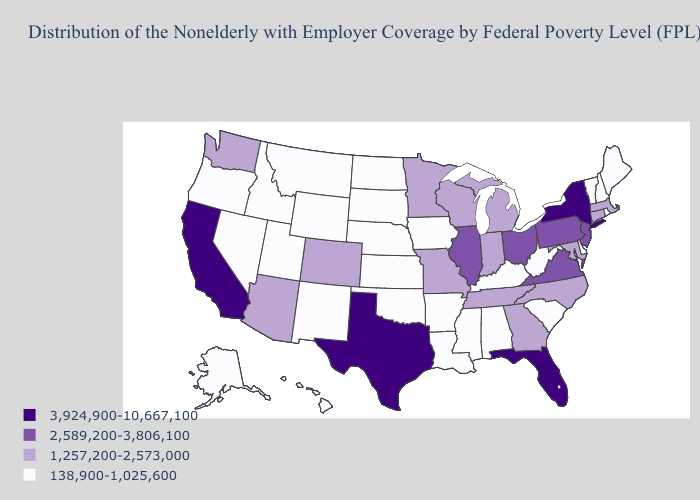What is the value of Indiana?
Give a very brief answer. 1,257,200-2,573,000. What is the value of California?
Give a very brief answer. 3,924,900-10,667,100. Which states have the highest value in the USA?
Short answer required. California, Florida, New York, Texas. What is the lowest value in states that border Vermont?
Give a very brief answer. 138,900-1,025,600. Among the states that border Pennsylvania , which have the highest value?
Short answer required. New York. What is the highest value in states that border New Hampshire?
Concise answer only. 1,257,200-2,573,000. Does the first symbol in the legend represent the smallest category?
Short answer required. No. Which states have the highest value in the USA?
Answer briefly. California, Florida, New York, Texas. How many symbols are there in the legend?
Concise answer only. 4. Name the states that have a value in the range 2,589,200-3,806,100?
Quick response, please. Illinois, New Jersey, Ohio, Pennsylvania, Virginia. Name the states that have a value in the range 1,257,200-2,573,000?
Concise answer only. Arizona, Colorado, Connecticut, Georgia, Indiana, Maryland, Massachusetts, Michigan, Minnesota, Missouri, North Carolina, Tennessee, Washington, Wisconsin. What is the value of California?
Give a very brief answer. 3,924,900-10,667,100. What is the value of Nevada?
Concise answer only. 138,900-1,025,600. Does New York have the highest value in the USA?
Answer briefly. Yes. Does New York have the highest value in the Northeast?
Answer briefly. Yes. 